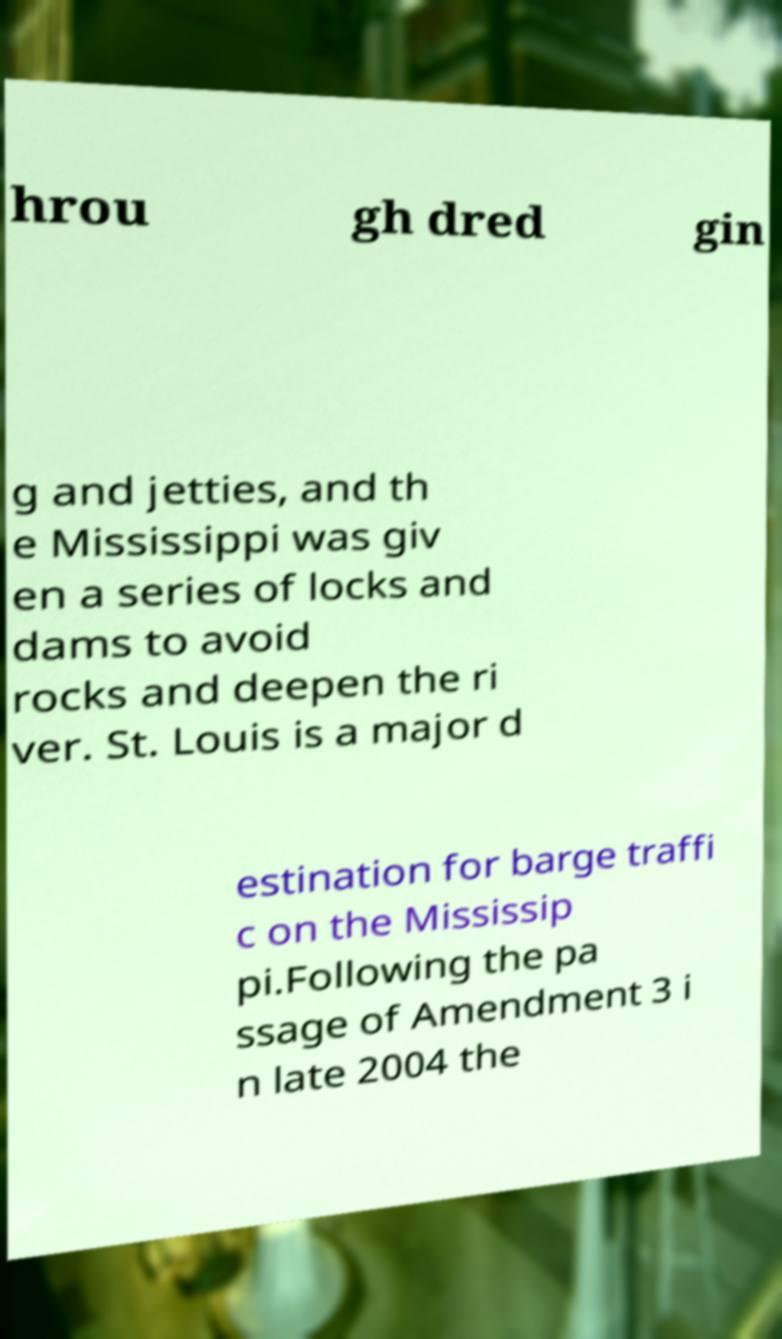For documentation purposes, I need the text within this image transcribed. Could you provide that? hrou gh dred gin g and jetties, and th e Mississippi was giv en a series of locks and dams to avoid rocks and deepen the ri ver. St. Louis is a major d estination for barge traffi c on the Mississip pi.Following the pa ssage of Amendment 3 i n late 2004 the 